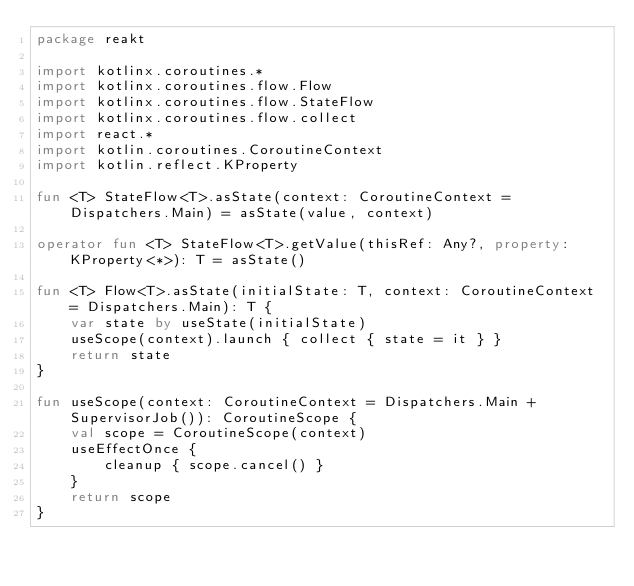Convert code to text. <code><loc_0><loc_0><loc_500><loc_500><_Kotlin_>package reakt

import kotlinx.coroutines.*
import kotlinx.coroutines.flow.Flow
import kotlinx.coroutines.flow.StateFlow
import kotlinx.coroutines.flow.collect
import react.*
import kotlin.coroutines.CoroutineContext
import kotlin.reflect.KProperty

fun <T> StateFlow<T>.asState(context: CoroutineContext = Dispatchers.Main) = asState(value, context)

operator fun <T> StateFlow<T>.getValue(thisRef: Any?, property: KProperty<*>): T = asState()

fun <T> Flow<T>.asState(initialState: T, context: CoroutineContext = Dispatchers.Main): T {
    var state by useState(initialState)
    useScope(context).launch { collect { state = it } }
    return state
}

fun useScope(context: CoroutineContext = Dispatchers.Main + SupervisorJob()): CoroutineScope {
    val scope = CoroutineScope(context)
    useEffectOnce {
        cleanup { scope.cancel() }
    }
    return scope
}</code> 